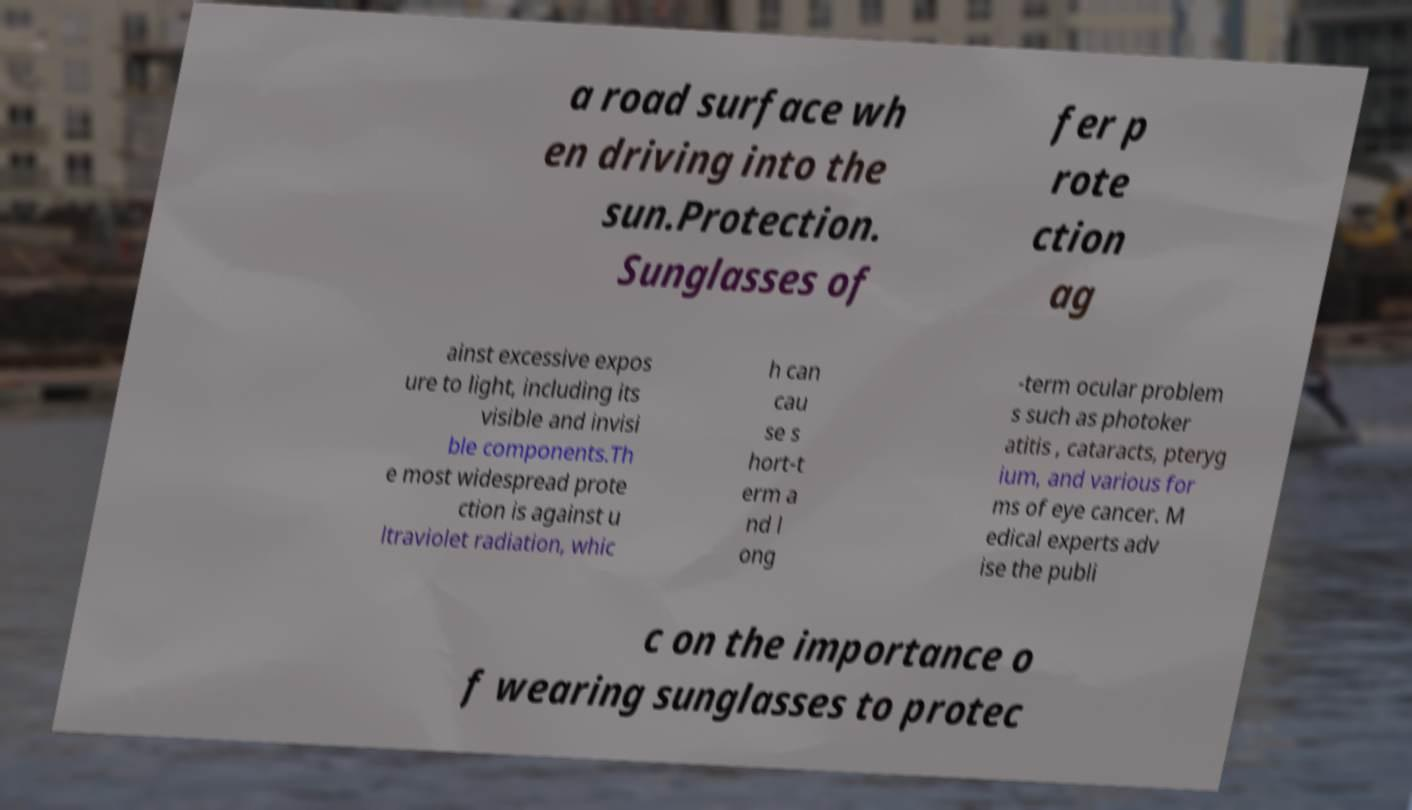Could you assist in decoding the text presented in this image and type it out clearly? a road surface wh en driving into the sun.Protection. Sunglasses of fer p rote ction ag ainst excessive expos ure to light, including its visible and invisi ble components.Th e most widespread prote ction is against u ltraviolet radiation, whic h can cau se s hort-t erm a nd l ong -term ocular problem s such as photoker atitis , cataracts, pteryg ium, and various for ms of eye cancer. M edical experts adv ise the publi c on the importance o f wearing sunglasses to protec 